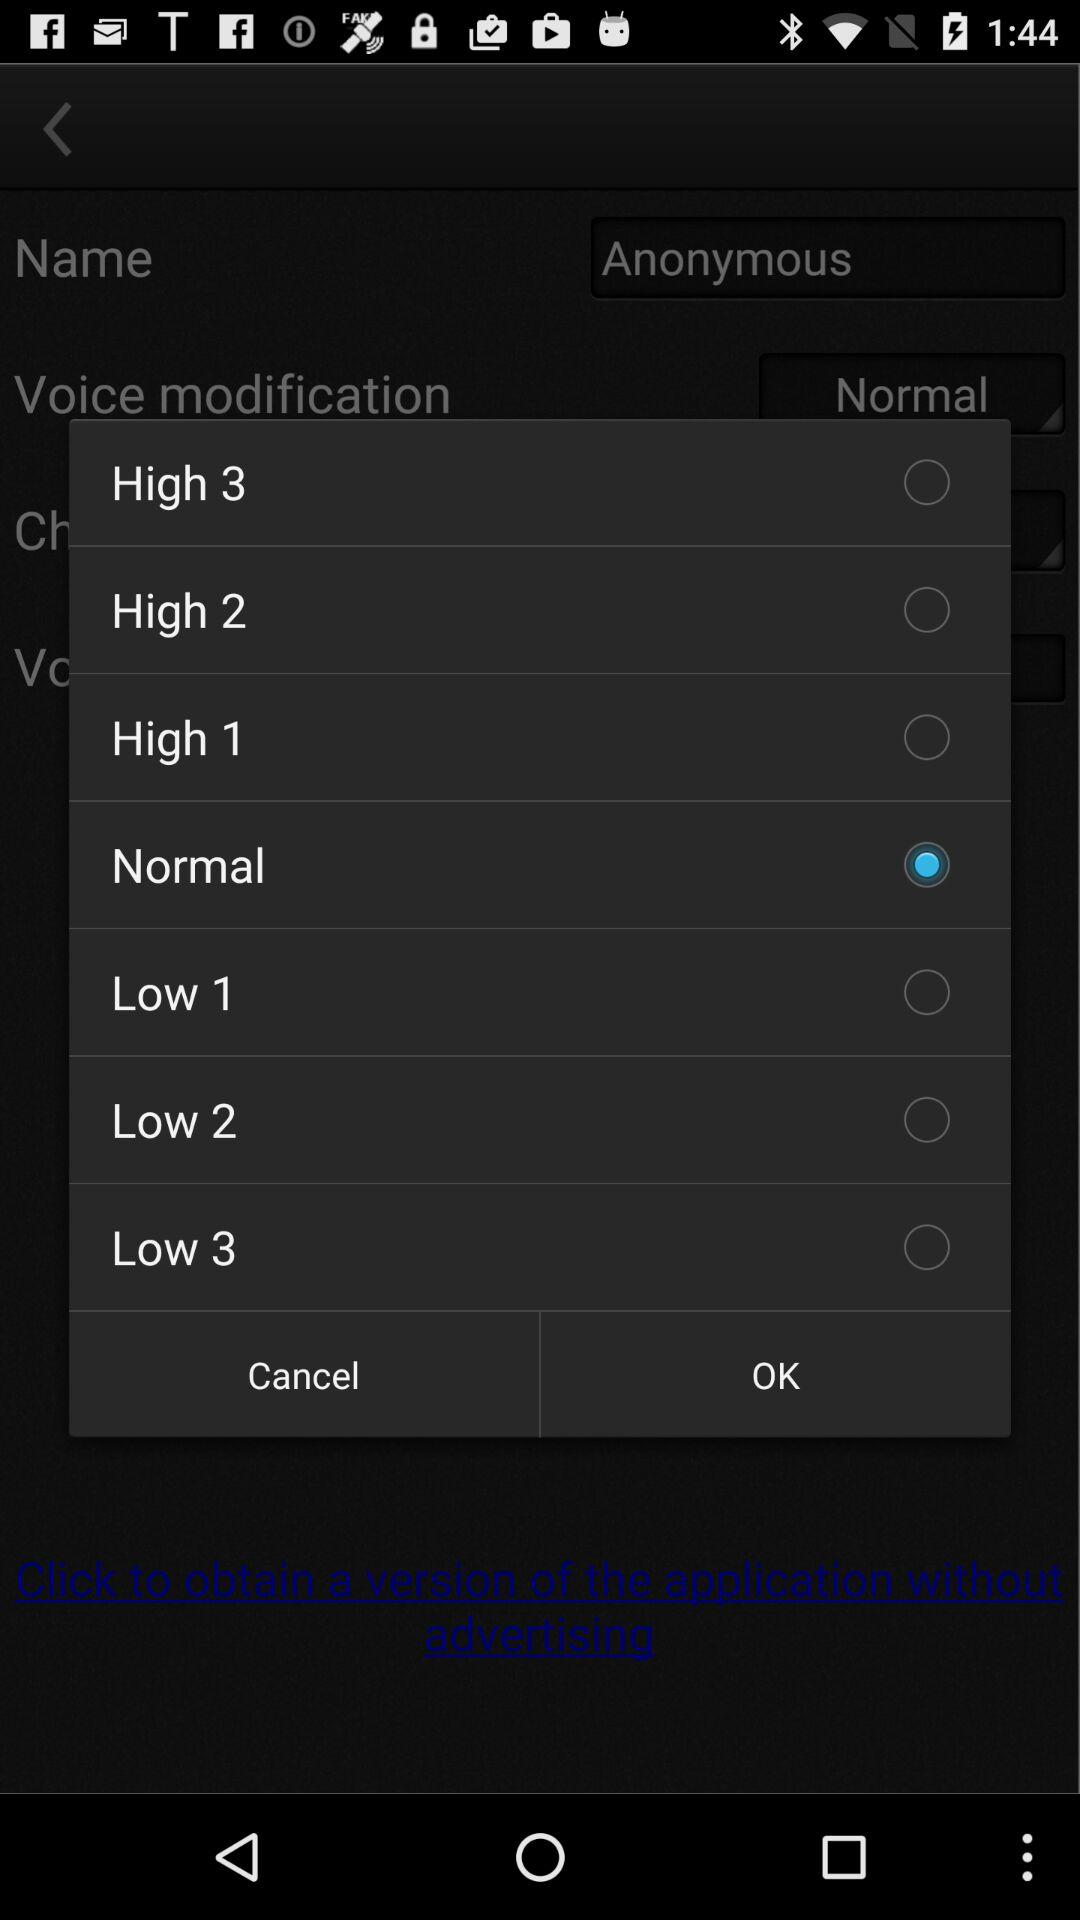What's the Highest Volume can be selected?
When the provided information is insufficient, respond with <no answer>. <no answer> 